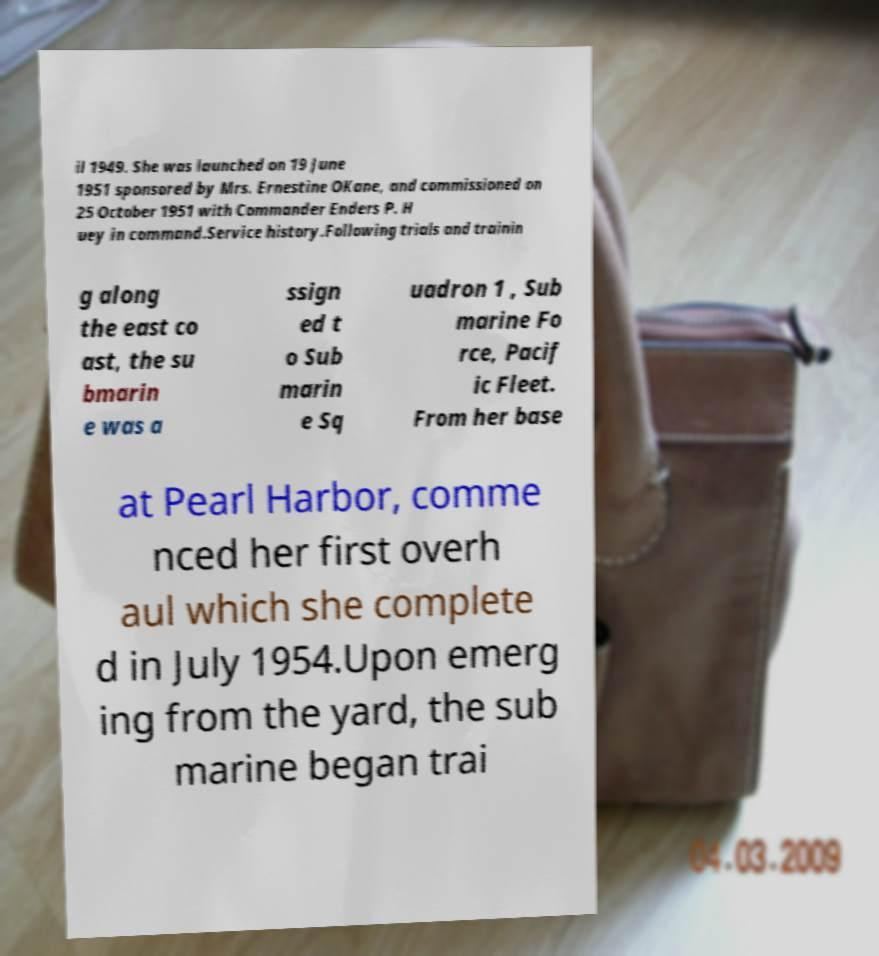Please identify and transcribe the text found in this image. il 1949. She was launched on 19 June 1951 sponsored by Mrs. Ernestine OKane, and commissioned on 25 October 1951 with Commander Enders P. H uey in command.Service history.Following trials and trainin g along the east co ast, the su bmarin e was a ssign ed t o Sub marin e Sq uadron 1 , Sub marine Fo rce, Pacif ic Fleet. From her base at Pearl Harbor, comme nced her first overh aul which she complete d in July 1954.Upon emerg ing from the yard, the sub marine began trai 